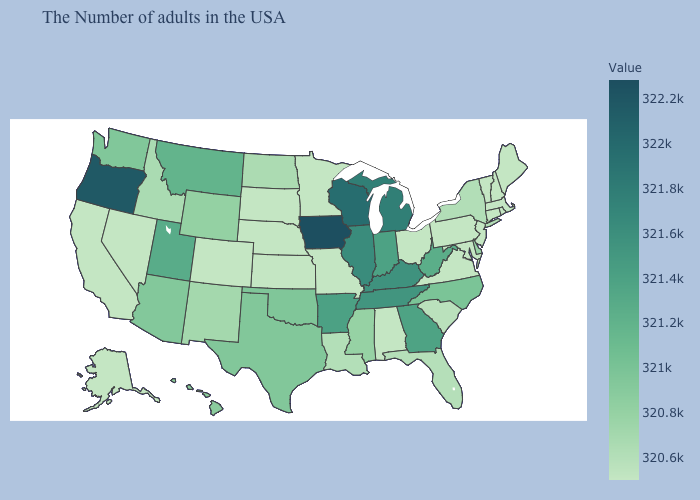Which states have the lowest value in the West?
Quick response, please. Colorado, Nevada, California, Alaska. Among the states that border Kansas , does Oklahoma have the highest value?
Short answer required. Yes. Does Kansas have a lower value than Iowa?
Write a very short answer. Yes. Does Delaware have the lowest value in the USA?
Write a very short answer. No. 